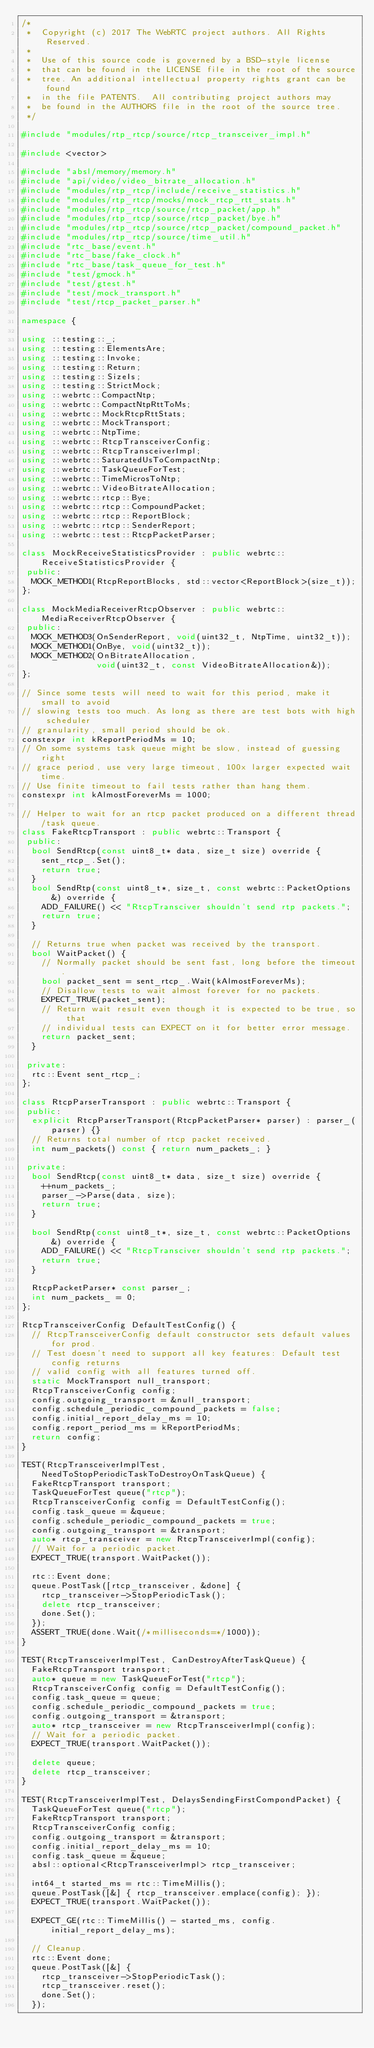Convert code to text. <code><loc_0><loc_0><loc_500><loc_500><_C++_>/*
 *  Copyright (c) 2017 The WebRTC project authors. All Rights Reserved.
 *
 *  Use of this source code is governed by a BSD-style license
 *  that can be found in the LICENSE file in the root of the source
 *  tree. An additional intellectual property rights grant can be found
 *  in the file PATENTS.  All contributing project authors may
 *  be found in the AUTHORS file in the root of the source tree.
 */

#include "modules/rtp_rtcp/source/rtcp_transceiver_impl.h"

#include <vector>

#include "absl/memory/memory.h"
#include "api/video/video_bitrate_allocation.h"
#include "modules/rtp_rtcp/include/receive_statistics.h"
#include "modules/rtp_rtcp/mocks/mock_rtcp_rtt_stats.h"
#include "modules/rtp_rtcp/source/rtcp_packet/app.h"
#include "modules/rtp_rtcp/source/rtcp_packet/bye.h"
#include "modules/rtp_rtcp/source/rtcp_packet/compound_packet.h"
#include "modules/rtp_rtcp/source/time_util.h"
#include "rtc_base/event.h"
#include "rtc_base/fake_clock.h"
#include "rtc_base/task_queue_for_test.h"
#include "test/gmock.h"
#include "test/gtest.h"
#include "test/mock_transport.h"
#include "test/rtcp_packet_parser.h"

namespace {

using ::testing::_;
using ::testing::ElementsAre;
using ::testing::Invoke;
using ::testing::Return;
using ::testing::SizeIs;
using ::testing::StrictMock;
using ::webrtc::CompactNtp;
using ::webrtc::CompactNtpRttToMs;
using ::webrtc::MockRtcpRttStats;
using ::webrtc::MockTransport;
using ::webrtc::NtpTime;
using ::webrtc::RtcpTransceiverConfig;
using ::webrtc::RtcpTransceiverImpl;
using ::webrtc::SaturatedUsToCompactNtp;
using ::webrtc::TaskQueueForTest;
using ::webrtc::TimeMicrosToNtp;
using ::webrtc::VideoBitrateAllocation;
using ::webrtc::rtcp::Bye;
using ::webrtc::rtcp::CompoundPacket;
using ::webrtc::rtcp::ReportBlock;
using ::webrtc::rtcp::SenderReport;
using ::webrtc::test::RtcpPacketParser;

class MockReceiveStatisticsProvider : public webrtc::ReceiveStatisticsProvider {
 public:
  MOCK_METHOD1(RtcpReportBlocks, std::vector<ReportBlock>(size_t));
};

class MockMediaReceiverRtcpObserver : public webrtc::MediaReceiverRtcpObserver {
 public:
  MOCK_METHOD3(OnSenderReport, void(uint32_t, NtpTime, uint32_t));
  MOCK_METHOD1(OnBye, void(uint32_t));
  MOCK_METHOD2(OnBitrateAllocation,
               void(uint32_t, const VideoBitrateAllocation&));
};

// Since some tests will need to wait for this period, make it small to avoid
// slowing tests too much. As long as there are test bots with high scheduler
// granularity, small period should be ok.
constexpr int kReportPeriodMs = 10;
// On some systems task queue might be slow, instead of guessing right
// grace period, use very large timeout, 100x larger expected wait time.
// Use finite timeout to fail tests rather than hang them.
constexpr int kAlmostForeverMs = 1000;

// Helper to wait for an rtcp packet produced on a different thread/task queue.
class FakeRtcpTransport : public webrtc::Transport {
 public:
  bool SendRtcp(const uint8_t* data, size_t size) override {
    sent_rtcp_.Set();
    return true;
  }
  bool SendRtp(const uint8_t*, size_t, const webrtc::PacketOptions&) override {
    ADD_FAILURE() << "RtcpTransciver shouldn't send rtp packets.";
    return true;
  }

  // Returns true when packet was received by the transport.
  bool WaitPacket() {
    // Normally packet should be sent fast, long before the timeout.
    bool packet_sent = sent_rtcp_.Wait(kAlmostForeverMs);
    // Disallow tests to wait almost forever for no packets.
    EXPECT_TRUE(packet_sent);
    // Return wait result even though it is expected to be true, so that
    // individual tests can EXPECT on it for better error message.
    return packet_sent;
  }

 private:
  rtc::Event sent_rtcp_;
};

class RtcpParserTransport : public webrtc::Transport {
 public:
  explicit RtcpParserTransport(RtcpPacketParser* parser) : parser_(parser) {}
  // Returns total number of rtcp packet received.
  int num_packets() const { return num_packets_; }

 private:
  bool SendRtcp(const uint8_t* data, size_t size) override {
    ++num_packets_;
    parser_->Parse(data, size);
    return true;
  }

  bool SendRtp(const uint8_t*, size_t, const webrtc::PacketOptions&) override {
    ADD_FAILURE() << "RtcpTransciver shouldn't send rtp packets.";
    return true;
  }

  RtcpPacketParser* const parser_;
  int num_packets_ = 0;
};

RtcpTransceiverConfig DefaultTestConfig() {
  // RtcpTransceiverConfig default constructor sets default values for prod.
  // Test doesn't need to support all key features: Default test config returns
  // valid config with all features turned off.
  static MockTransport null_transport;
  RtcpTransceiverConfig config;
  config.outgoing_transport = &null_transport;
  config.schedule_periodic_compound_packets = false;
  config.initial_report_delay_ms = 10;
  config.report_period_ms = kReportPeriodMs;
  return config;
}

TEST(RtcpTransceiverImplTest, NeedToStopPeriodicTaskToDestroyOnTaskQueue) {
  FakeRtcpTransport transport;
  TaskQueueForTest queue("rtcp");
  RtcpTransceiverConfig config = DefaultTestConfig();
  config.task_queue = &queue;
  config.schedule_periodic_compound_packets = true;
  config.outgoing_transport = &transport;
  auto* rtcp_transceiver = new RtcpTransceiverImpl(config);
  // Wait for a periodic packet.
  EXPECT_TRUE(transport.WaitPacket());

  rtc::Event done;
  queue.PostTask([rtcp_transceiver, &done] {
    rtcp_transceiver->StopPeriodicTask();
    delete rtcp_transceiver;
    done.Set();
  });
  ASSERT_TRUE(done.Wait(/*milliseconds=*/1000));
}

TEST(RtcpTransceiverImplTest, CanDestroyAfterTaskQueue) {
  FakeRtcpTransport transport;
  auto* queue = new TaskQueueForTest("rtcp");
  RtcpTransceiverConfig config = DefaultTestConfig();
  config.task_queue = queue;
  config.schedule_periodic_compound_packets = true;
  config.outgoing_transport = &transport;
  auto* rtcp_transceiver = new RtcpTransceiverImpl(config);
  // Wait for a periodic packet.
  EXPECT_TRUE(transport.WaitPacket());

  delete queue;
  delete rtcp_transceiver;
}

TEST(RtcpTransceiverImplTest, DelaysSendingFirstCompondPacket) {
  TaskQueueForTest queue("rtcp");
  FakeRtcpTransport transport;
  RtcpTransceiverConfig config;
  config.outgoing_transport = &transport;
  config.initial_report_delay_ms = 10;
  config.task_queue = &queue;
  absl::optional<RtcpTransceiverImpl> rtcp_transceiver;

  int64_t started_ms = rtc::TimeMillis();
  queue.PostTask([&] { rtcp_transceiver.emplace(config); });
  EXPECT_TRUE(transport.WaitPacket());

  EXPECT_GE(rtc::TimeMillis() - started_ms, config.initial_report_delay_ms);

  // Cleanup.
  rtc::Event done;
  queue.PostTask([&] {
    rtcp_transceiver->StopPeriodicTask();
    rtcp_transceiver.reset();
    done.Set();
  });</code> 